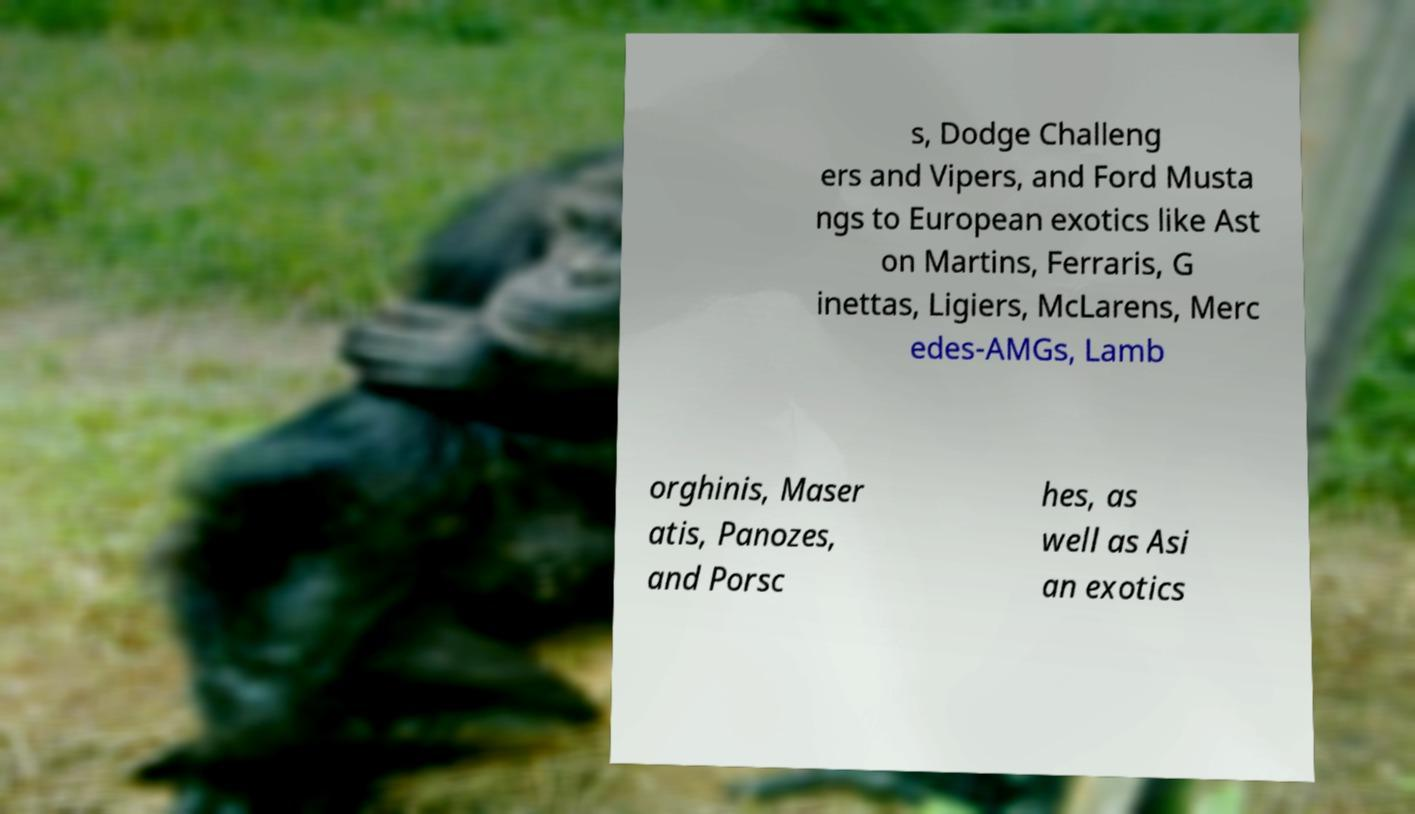Can you read and provide the text displayed in the image?This photo seems to have some interesting text. Can you extract and type it out for me? s, Dodge Challeng ers and Vipers, and Ford Musta ngs to European exotics like Ast on Martins, Ferraris, G inettas, Ligiers, McLarens, Merc edes-AMGs, Lamb orghinis, Maser atis, Panozes, and Porsc hes, as well as Asi an exotics 